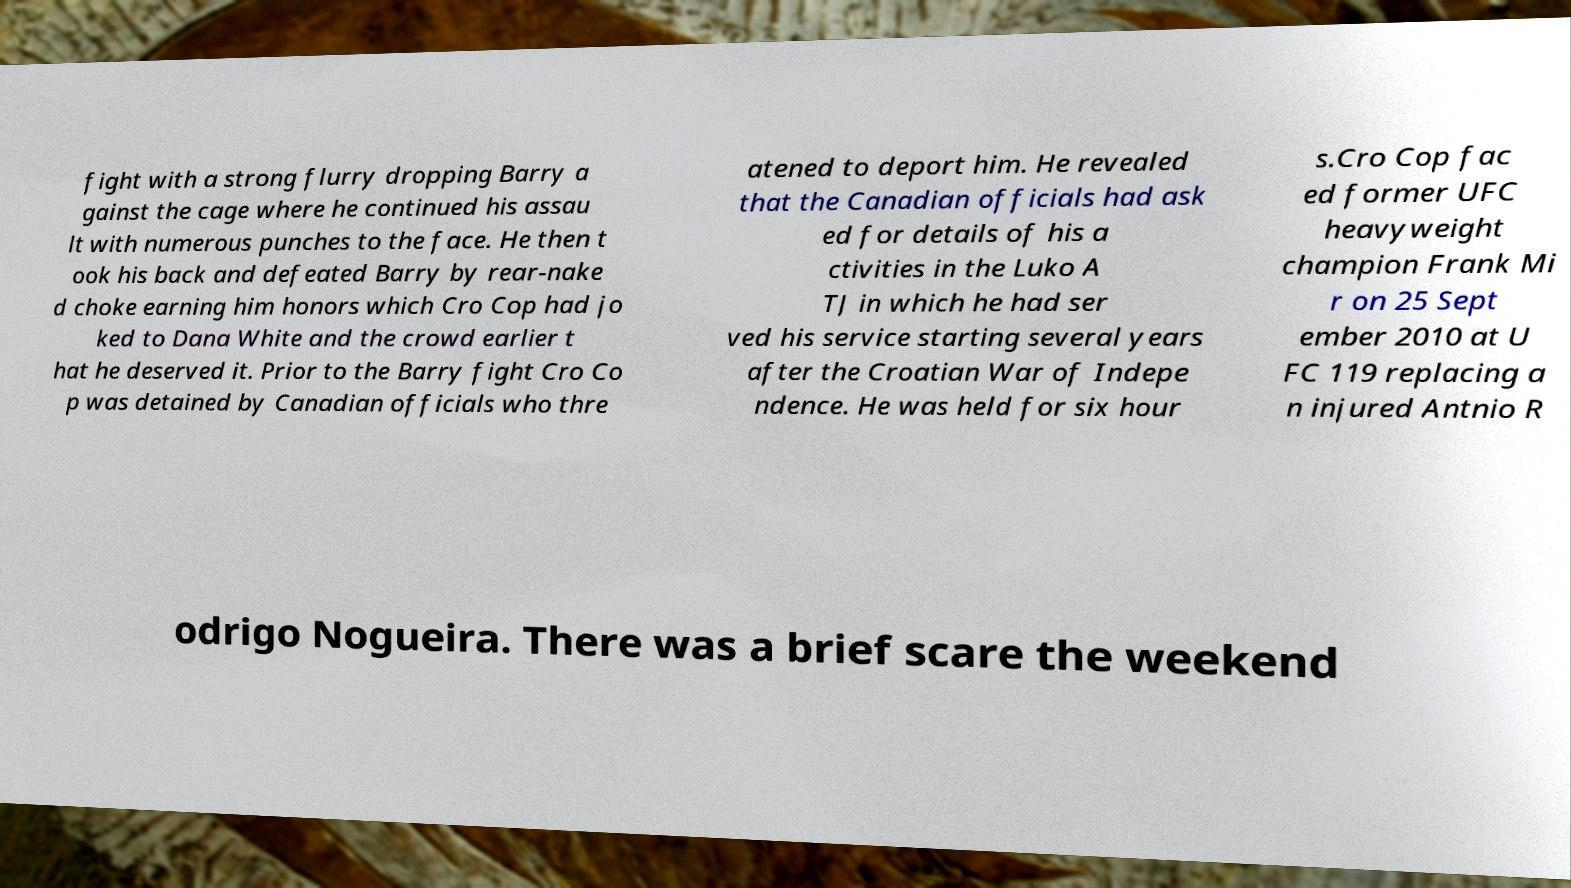There's text embedded in this image that I need extracted. Can you transcribe it verbatim? fight with a strong flurry dropping Barry a gainst the cage where he continued his assau lt with numerous punches to the face. He then t ook his back and defeated Barry by rear-nake d choke earning him honors which Cro Cop had jo ked to Dana White and the crowd earlier t hat he deserved it. Prior to the Barry fight Cro Co p was detained by Canadian officials who thre atened to deport him. He revealed that the Canadian officials had ask ed for details of his a ctivities in the Luko A TJ in which he had ser ved his service starting several years after the Croatian War of Indepe ndence. He was held for six hour s.Cro Cop fac ed former UFC heavyweight champion Frank Mi r on 25 Sept ember 2010 at U FC 119 replacing a n injured Antnio R odrigo Nogueira. There was a brief scare the weekend 